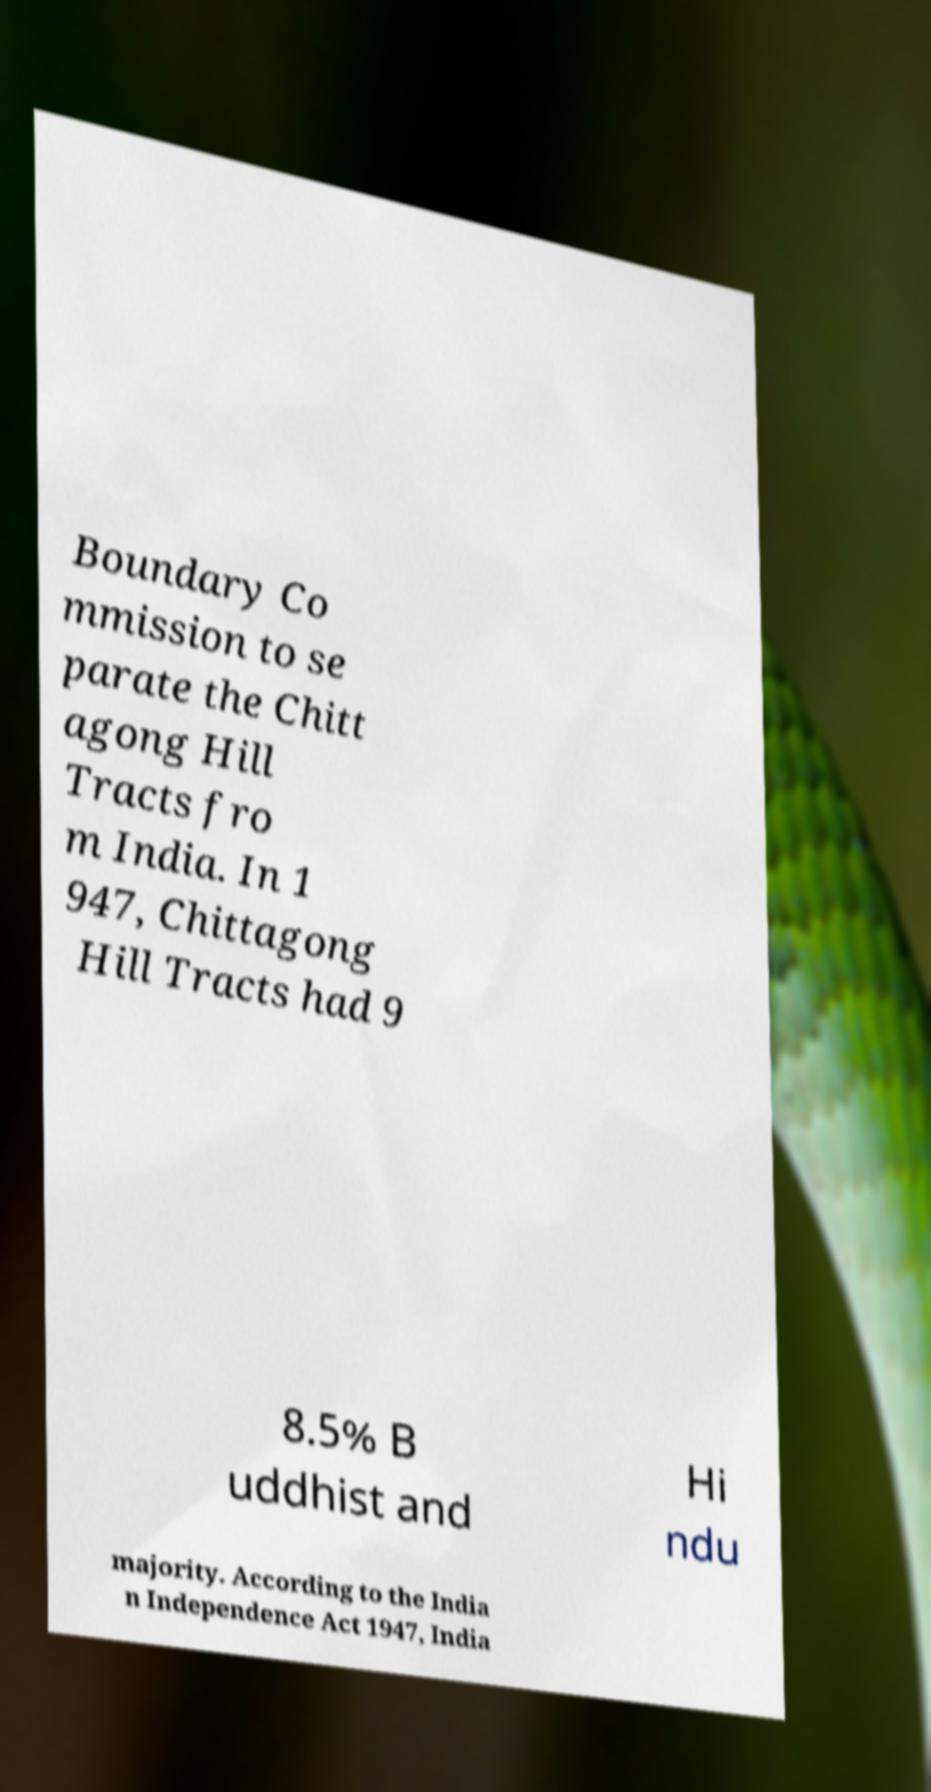For documentation purposes, I need the text within this image transcribed. Could you provide that? Boundary Co mmission to se parate the Chitt agong Hill Tracts fro m India. In 1 947, Chittagong Hill Tracts had 9 8.5% B uddhist and Hi ndu majority. According to the India n Independence Act 1947, India 